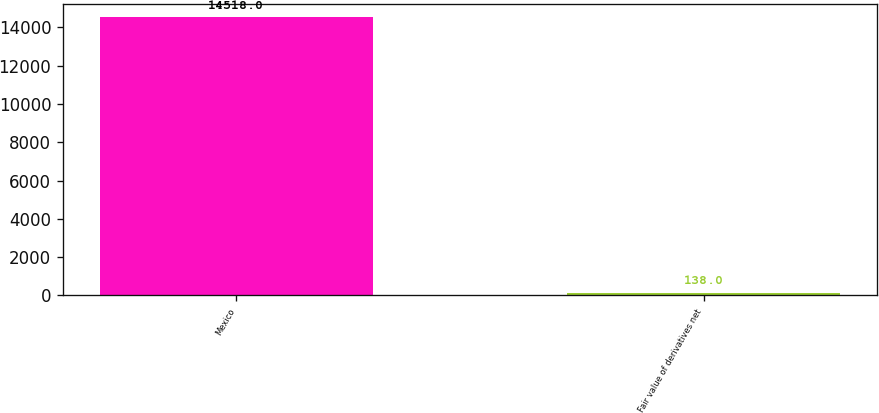<chart> <loc_0><loc_0><loc_500><loc_500><bar_chart><fcel>Mexico<fcel>Fair value of derivatives net<nl><fcel>14518<fcel>138<nl></chart> 